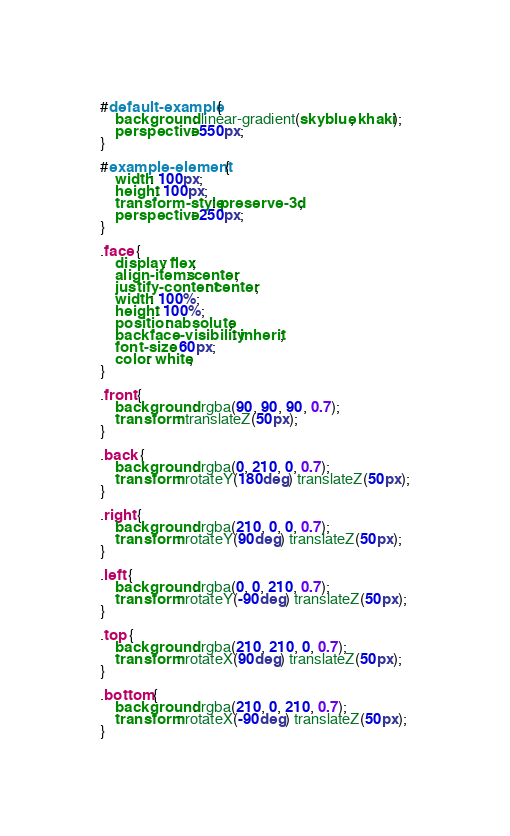Convert code to text. <code><loc_0><loc_0><loc_500><loc_500><_CSS_>#default-example {
    background: linear-gradient(skyblue, khaki);
    perspective: 550px;
}

#example-element {
    width: 100px;
    height: 100px;
    transform-style: preserve-3d;
    perspective: 250px;
}

.face {
    display: flex;
    align-items: center;
    justify-content: center;
    width: 100%;
    height: 100%;
    position: absolute;
    backface-visibility: inherit;
    font-size: 60px;
    color: white;
}

.front {
    background: rgba(90, 90, 90, 0.7);
    transform: translateZ(50px);
}

.back {
    background: rgba(0, 210, 0, 0.7);
    transform: rotateY(180deg) translateZ(50px);
}

.right {
    background: rgba(210, 0, 0, 0.7);
    transform: rotateY(90deg) translateZ(50px);
}

.left {
    background: rgba(0, 0, 210, 0.7);
    transform: rotateY(-90deg) translateZ(50px);
}

.top {
    background: rgba(210, 210, 0, 0.7);
    transform: rotateX(90deg) translateZ(50px);
}

.bottom {
    background: rgba(210, 0, 210, 0.7);
    transform: rotateX(-90deg) translateZ(50px);
}
</code> 